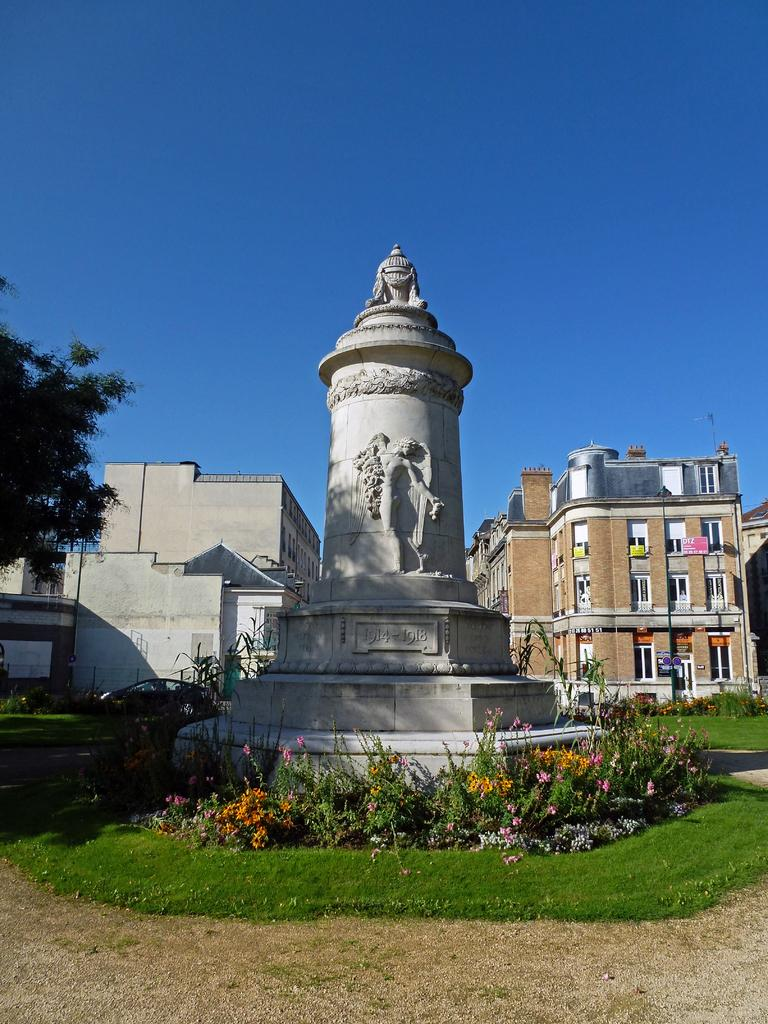What type of vegetation can be seen in the image? There is grass, plants, and flowers in the image. What type of structures are present in the image? There are buildings in the image. What mode of transportation can be seen in the image? There is a vehicle in the image. What type of tree is present in the image? There is a tree in the image. What is visible at the top of the image? The sky is visible at the top of the image. What type of attraction can be seen in the image? There is no attraction present in the image; it features grass, plants, flowers, buildings, a vehicle, a tree, and the sky. What type of pies are being sold at the popcorn stand in the image? There is no popcorn stand or pies present in the image. 